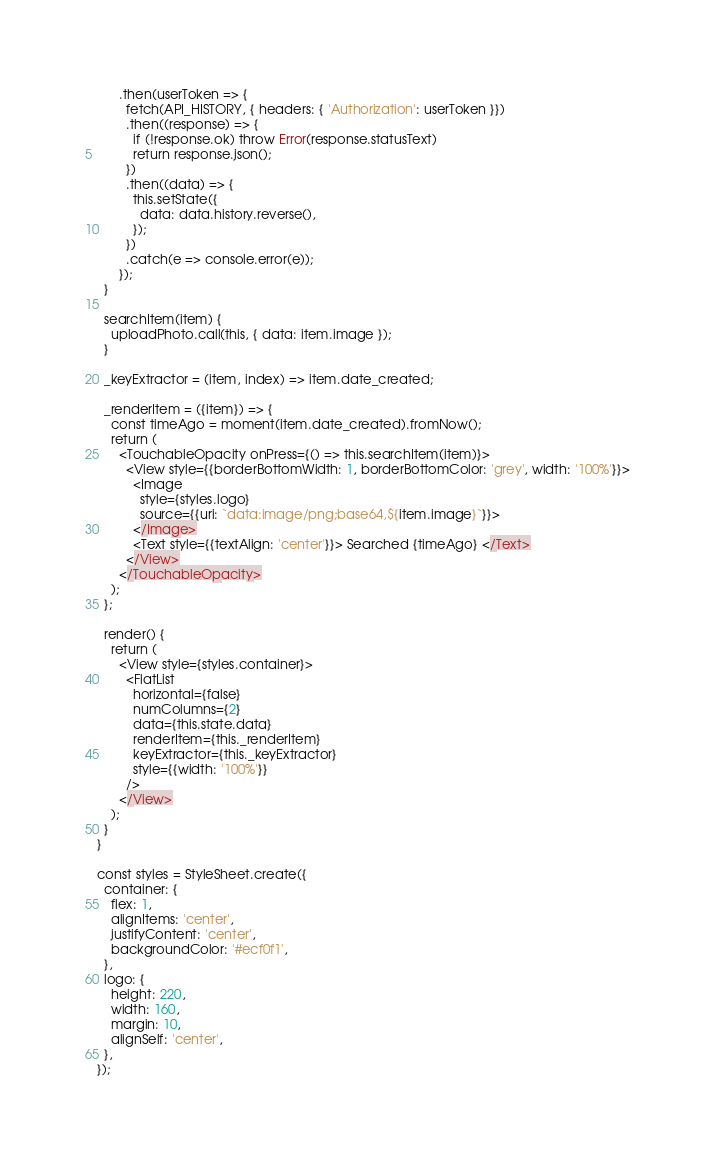<code> <loc_0><loc_0><loc_500><loc_500><_JavaScript_>      .then(userToken => {
        fetch(API_HISTORY, { headers: { 'Authorization': userToken }})
        .then((response) => {
          if (!response.ok) throw Error(response.statusText)
          return response.json();
        })
        .then((data) => {
          this.setState({
            data: data.history.reverse(),
          });
        })
        .catch(e => console.error(e));
      });
  }

  searchItem(item) {
    uploadPhoto.call(this, { data: item.image });
  }

  _keyExtractor = (item, index) => item.date_created;

  _renderItem = ({item}) => {
    const timeAgo = moment(item.date_created).fromNow();
    return (
      <TouchableOpacity onPress={() => this.searchItem(item)}>
        <View style={{borderBottomWidth: 1, borderBottomColor: 'grey', width: '100%'}}>
          <Image
            style={styles.logo}
            source={{uri: `data:image/png;base64,${item.image}`}}>
          </Image>
          <Text style={{textAlign: 'center'}}> Searched {timeAgo} </Text>
        </View>
      </TouchableOpacity>
    );
  };

  render() {
    return (
      <View style={styles.container}>
        <FlatList
          horizontal={false}
          numColumns={2}
          data={this.state.data}
          renderItem={this._renderItem}
          keyExtractor={this._keyExtractor}
          style={{width: '100%'}}
        />
      </View>
    );
  }
}

const styles = StyleSheet.create({
  container: {
    flex: 1,
    alignItems: 'center',
    justifyContent: 'center',
    backgroundColor: '#ecf0f1',
  },
  logo: {
    height: 220,
    width: 160,
    margin: 10,
    alignSelf: 'center',
  },
});
</code> 